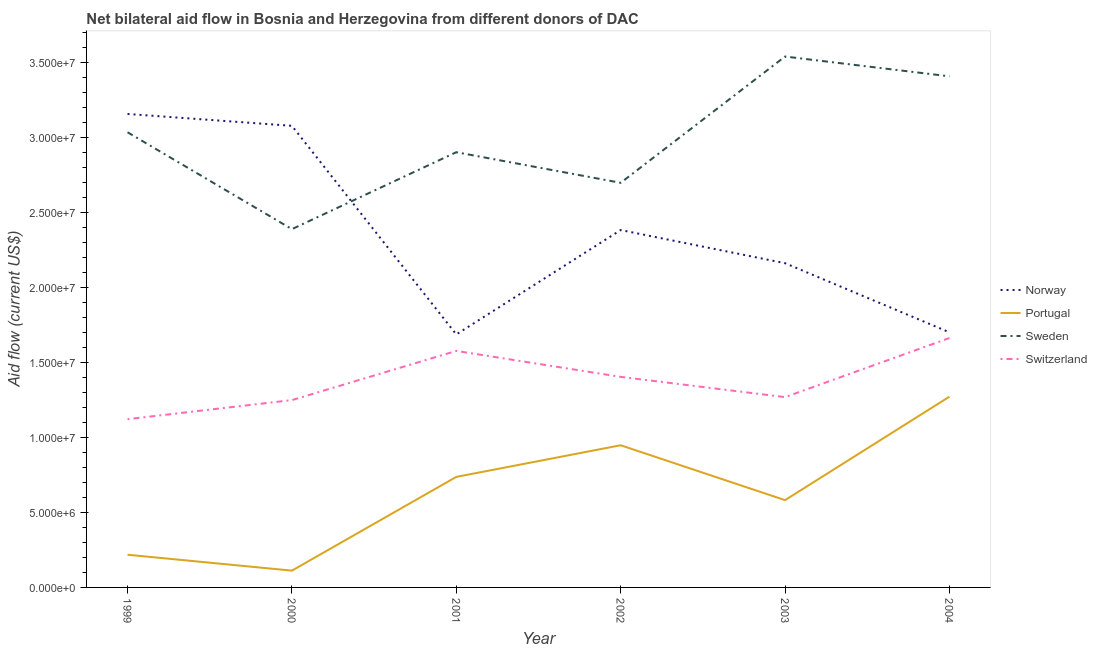Does the line corresponding to amount of aid given by portugal intersect with the line corresponding to amount of aid given by sweden?
Make the answer very short. No. What is the amount of aid given by sweden in 2003?
Offer a very short reply. 3.54e+07. Across all years, what is the maximum amount of aid given by switzerland?
Give a very brief answer. 1.66e+07. Across all years, what is the minimum amount of aid given by switzerland?
Keep it short and to the point. 1.12e+07. In which year was the amount of aid given by sweden minimum?
Offer a terse response. 2000. What is the total amount of aid given by norway in the graph?
Your answer should be compact. 1.42e+08. What is the difference between the amount of aid given by norway in 1999 and that in 2004?
Make the answer very short. 1.46e+07. What is the difference between the amount of aid given by sweden in 2000 and the amount of aid given by norway in 1999?
Provide a short and direct response. -7.68e+06. What is the average amount of aid given by sweden per year?
Make the answer very short. 3.00e+07. In the year 1999, what is the difference between the amount of aid given by switzerland and amount of aid given by portugal?
Keep it short and to the point. 9.04e+06. In how many years, is the amount of aid given by norway greater than 31000000 US$?
Offer a very short reply. 1. What is the ratio of the amount of aid given by sweden in 2000 to that in 2001?
Provide a succinct answer. 0.82. What is the difference between the highest and the second highest amount of aid given by norway?
Offer a very short reply. 7.90e+05. What is the difference between the highest and the lowest amount of aid given by norway?
Make the answer very short. 1.47e+07. In how many years, is the amount of aid given by switzerland greater than the average amount of aid given by switzerland taken over all years?
Your answer should be compact. 3. Is the sum of the amount of aid given by sweden in 2000 and 2002 greater than the maximum amount of aid given by portugal across all years?
Ensure brevity in your answer.  Yes. Is it the case that in every year, the sum of the amount of aid given by switzerland and amount of aid given by portugal is greater than the sum of amount of aid given by sweden and amount of aid given by norway?
Provide a short and direct response. No. Is the amount of aid given by portugal strictly greater than the amount of aid given by norway over the years?
Your response must be concise. No. Is the amount of aid given by portugal strictly less than the amount of aid given by sweden over the years?
Ensure brevity in your answer.  Yes. How many lines are there?
Ensure brevity in your answer.  4. How many years are there in the graph?
Provide a short and direct response. 6. Where does the legend appear in the graph?
Ensure brevity in your answer.  Center right. How many legend labels are there?
Make the answer very short. 4. What is the title of the graph?
Keep it short and to the point. Net bilateral aid flow in Bosnia and Herzegovina from different donors of DAC. Does "Public sector management" appear as one of the legend labels in the graph?
Your answer should be compact. No. What is the label or title of the X-axis?
Ensure brevity in your answer.  Year. What is the label or title of the Y-axis?
Your answer should be compact. Aid flow (current US$). What is the Aid flow (current US$) of Norway in 1999?
Provide a succinct answer. 3.16e+07. What is the Aid flow (current US$) of Portugal in 1999?
Give a very brief answer. 2.18e+06. What is the Aid flow (current US$) of Sweden in 1999?
Offer a very short reply. 3.04e+07. What is the Aid flow (current US$) in Switzerland in 1999?
Your answer should be very brief. 1.12e+07. What is the Aid flow (current US$) in Norway in 2000?
Make the answer very short. 3.08e+07. What is the Aid flow (current US$) of Portugal in 2000?
Provide a short and direct response. 1.12e+06. What is the Aid flow (current US$) of Sweden in 2000?
Keep it short and to the point. 2.39e+07. What is the Aid flow (current US$) in Switzerland in 2000?
Keep it short and to the point. 1.25e+07. What is the Aid flow (current US$) of Norway in 2001?
Provide a succinct answer. 1.69e+07. What is the Aid flow (current US$) of Portugal in 2001?
Make the answer very short. 7.37e+06. What is the Aid flow (current US$) in Sweden in 2001?
Your answer should be compact. 2.90e+07. What is the Aid flow (current US$) in Switzerland in 2001?
Provide a succinct answer. 1.58e+07. What is the Aid flow (current US$) of Norway in 2002?
Your response must be concise. 2.38e+07. What is the Aid flow (current US$) in Portugal in 2002?
Keep it short and to the point. 9.48e+06. What is the Aid flow (current US$) of Sweden in 2002?
Your answer should be very brief. 2.70e+07. What is the Aid flow (current US$) of Switzerland in 2002?
Make the answer very short. 1.40e+07. What is the Aid flow (current US$) in Norway in 2003?
Offer a very short reply. 2.16e+07. What is the Aid flow (current US$) in Portugal in 2003?
Your answer should be very brief. 5.82e+06. What is the Aid flow (current US$) of Sweden in 2003?
Keep it short and to the point. 3.54e+07. What is the Aid flow (current US$) of Switzerland in 2003?
Keep it short and to the point. 1.27e+07. What is the Aid flow (current US$) of Norway in 2004?
Keep it short and to the point. 1.70e+07. What is the Aid flow (current US$) of Portugal in 2004?
Keep it short and to the point. 1.27e+07. What is the Aid flow (current US$) of Sweden in 2004?
Keep it short and to the point. 3.41e+07. What is the Aid flow (current US$) of Switzerland in 2004?
Your answer should be very brief. 1.66e+07. Across all years, what is the maximum Aid flow (current US$) in Norway?
Offer a very short reply. 3.16e+07. Across all years, what is the maximum Aid flow (current US$) in Portugal?
Your response must be concise. 1.27e+07. Across all years, what is the maximum Aid flow (current US$) of Sweden?
Provide a succinct answer. 3.54e+07. Across all years, what is the maximum Aid flow (current US$) of Switzerland?
Offer a very short reply. 1.66e+07. Across all years, what is the minimum Aid flow (current US$) in Norway?
Ensure brevity in your answer.  1.69e+07. Across all years, what is the minimum Aid flow (current US$) in Portugal?
Your response must be concise. 1.12e+06. Across all years, what is the minimum Aid flow (current US$) of Sweden?
Provide a short and direct response. 2.39e+07. Across all years, what is the minimum Aid flow (current US$) in Switzerland?
Your answer should be very brief. 1.12e+07. What is the total Aid flow (current US$) in Norway in the graph?
Your answer should be compact. 1.42e+08. What is the total Aid flow (current US$) in Portugal in the graph?
Give a very brief answer. 3.87e+07. What is the total Aid flow (current US$) of Sweden in the graph?
Provide a short and direct response. 1.80e+08. What is the total Aid flow (current US$) of Switzerland in the graph?
Offer a terse response. 8.28e+07. What is the difference between the Aid flow (current US$) in Norway in 1999 and that in 2000?
Provide a short and direct response. 7.90e+05. What is the difference between the Aid flow (current US$) in Portugal in 1999 and that in 2000?
Provide a short and direct response. 1.06e+06. What is the difference between the Aid flow (current US$) in Sweden in 1999 and that in 2000?
Keep it short and to the point. 6.46e+06. What is the difference between the Aid flow (current US$) of Switzerland in 1999 and that in 2000?
Keep it short and to the point. -1.27e+06. What is the difference between the Aid flow (current US$) of Norway in 1999 and that in 2001?
Offer a very short reply. 1.47e+07. What is the difference between the Aid flow (current US$) of Portugal in 1999 and that in 2001?
Provide a short and direct response. -5.19e+06. What is the difference between the Aid flow (current US$) in Sweden in 1999 and that in 2001?
Give a very brief answer. 1.33e+06. What is the difference between the Aid flow (current US$) in Switzerland in 1999 and that in 2001?
Offer a terse response. -4.55e+06. What is the difference between the Aid flow (current US$) of Norway in 1999 and that in 2002?
Give a very brief answer. 7.74e+06. What is the difference between the Aid flow (current US$) of Portugal in 1999 and that in 2002?
Provide a short and direct response. -7.30e+06. What is the difference between the Aid flow (current US$) in Sweden in 1999 and that in 2002?
Make the answer very short. 3.37e+06. What is the difference between the Aid flow (current US$) of Switzerland in 1999 and that in 2002?
Your answer should be compact. -2.82e+06. What is the difference between the Aid flow (current US$) of Norway in 1999 and that in 2003?
Your answer should be compact. 9.95e+06. What is the difference between the Aid flow (current US$) in Portugal in 1999 and that in 2003?
Your answer should be very brief. -3.64e+06. What is the difference between the Aid flow (current US$) of Sweden in 1999 and that in 2003?
Make the answer very short. -5.05e+06. What is the difference between the Aid flow (current US$) in Switzerland in 1999 and that in 2003?
Your answer should be very brief. -1.47e+06. What is the difference between the Aid flow (current US$) in Norway in 1999 and that in 2004?
Keep it short and to the point. 1.46e+07. What is the difference between the Aid flow (current US$) of Portugal in 1999 and that in 2004?
Provide a short and direct response. -1.05e+07. What is the difference between the Aid flow (current US$) of Sweden in 1999 and that in 2004?
Make the answer very short. -3.73e+06. What is the difference between the Aid flow (current US$) in Switzerland in 1999 and that in 2004?
Offer a very short reply. -5.41e+06. What is the difference between the Aid flow (current US$) of Norway in 2000 and that in 2001?
Give a very brief answer. 1.39e+07. What is the difference between the Aid flow (current US$) in Portugal in 2000 and that in 2001?
Make the answer very short. -6.25e+06. What is the difference between the Aid flow (current US$) of Sweden in 2000 and that in 2001?
Keep it short and to the point. -5.13e+06. What is the difference between the Aid flow (current US$) of Switzerland in 2000 and that in 2001?
Your response must be concise. -3.28e+06. What is the difference between the Aid flow (current US$) of Norway in 2000 and that in 2002?
Your answer should be very brief. 6.95e+06. What is the difference between the Aid flow (current US$) of Portugal in 2000 and that in 2002?
Your answer should be compact. -8.36e+06. What is the difference between the Aid flow (current US$) in Sweden in 2000 and that in 2002?
Your response must be concise. -3.09e+06. What is the difference between the Aid flow (current US$) in Switzerland in 2000 and that in 2002?
Your response must be concise. -1.55e+06. What is the difference between the Aid flow (current US$) in Norway in 2000 and that in 2003?
Your response must be concise. 9.16e+06. What is the difference between the Aid flow (current US$) of Portugal in 2000 and that in 2003?
Provide a short and direct response. -4.70e+06. What is the difference between the Aid flow (current US$) of Sweden in 2000 and that in 2003?
Keep it short and to the point. -1.15e+07. What is the difference between the Aid flow (current US$) in Switzerland in 2000 and that in 2003?
Provide a short and direct response. -2.00e+05. What is the difference between the Aid flow (current US$) of Norway in 2000 and that in 2004?
Provide a short and direct response. 1.38e+07. What is the difference between the Aid flow (current US$) of Portugal in 2000 and that in 2004?
Give a very brief answer. -1.16e+07. What is the difference between the Aid flow (current US$) in Sweden in 2000 and that in 2004?
Your answer should be very brief. -1.02e+07. What is the difference between the Aid flow (current US$) in Switzerland in 2000 and that in 2004?
Make the answer very short. -4.14e+06. What is the difference between the Aid flow (current US$) in Norway in 2001 and that in 2002?
Make the answer very short. -6.96e+06. What is the difference between the Aid flow (current US$) in Portugal in 2001 and that in 2002?
Provide a short and direct response. -2.11e+06. What is the difference between the Aid flow (current US$) of Sweden in 2001 and that in 2002?
Ensure brevity in your answer.  2.04e+06. What is the difference between the Aid flow (current US$) of Switzerland in 2001 and that in 2002?
Keep it short and to the point. 1.73e+06. What is the difference between the Aid flow (current US$) in Norway in 2001 and that in 2003?
Your answer should be compact. -4.75e+06. What is the difference between the Aid flow (current US$) in Portugal in 2001 and that in 2003?
Make the answer very short. 1.55e+06. What is the difference between the Aid flow (current US$) of Sweden in 2001 and that in 2003?
Your answer should be very brief. -6.38e+06. What is the difference between the Aid flow (current US$) in Switzerland in 2001 and that in 2003?
Your answer should be very brief. 3.08e+06. What is the difference between the Aid flow (current US$) in Norway in 2001 and that in 2004?
Offer a terse response. -1.40e+05. What is the difference between the Aid flow (current US$) of Portugal in 2001 and that in 2004?
Keep it short and to the point. -5.35e+06. What is the difference between the Aid flow (current US$) of Sweden in 2001 and that in 2004?
Offer a terse response. -5.06e+06. What is the difference between the Aid flow (current US$) in Switzerland in 2001 and that in 2004?
Provide a succinct answer. -8.60e+05. What is the difference between the Aid flow (current US$) in Norway in 2002 and that in 2003?
Your answer should be very brief. 2.21e+06. What is the difference between the Aid flow (current US$) in Portugal in 2002 and that in 2003?
Make the answer very short. 3.66e+06. What is the difference between the Aid flow (current US$) in Sweden in 2002 and that in 2003?
Provide a succinct answer. -8.42e+06. What is the difference between the Aid flow (current US$) in Switzerland in 2002 and that in 2003?
Your response must be concise. 1.35e+06. What is the difference between the Aid flow (current US$) in Norway in 2002 and that in 2004?
Give a very brief answer. 6.82e+06. What is the difference between the Aid flow (current US$) of Portugal in 2002 and that in 2004?
Your answer should be very brief. -3.24e+06. What is the difference between the Aid flow (current US$) in Sweden in 2002 and that in 2004?
Offer a terse response. -7.10e+06. What is the difference between the Aid flow (current US$) in Switzerland in 2002 and that in 2004?
Offer a very short reply. -2.59e+06. What is the difference between the Aid flow (current US$) in Norway in 2003 and that in 2004?
Keep it short and to the point. 4.61e+06. What is the difference between the Aid flow (current US$) in Portugal in 2003 and that in 2004?
Give a very brief answer. -6.90e+06. What is the difference between the Aid flow (current US$) of Sweden in 2003 and that in 2004?
Your response must be concise. 1.32e+06. What is the difference between the Aid flow (current US$) in Switzerland in 2003 and that in 2004?
Your answer should be compact. -3.94e+06. What is the difference between the Aid flow (current US$) in Norway in 1999 and the Aid flow (current US$) in Portugal in 2000?
Ensure brevity in your answer.  3.04e+07. What is the difference between the Aid flow (current US$) of Norway in 1999 and the Aid flow (current US$) of Sweden in 2000?
Offer a terse response. 7.68e+06. What is the difference between the Aid flow (current US$) of Norway in 1999 and the Aid flow (current US$) of Switzerland in 2000?
Your response must be concise. 1.91e+07. What is the difference between the Aid flow (current US$) in Portugal in 1999 and the Aid flow (current US$) in Sweden in 2000?
Give a very brief answer. -2.17e+07. What is the difference between the Aid flow (current US$) in Portugal in 1999 and the Aid flow (current US$) in Switzerland in 2000?
Offer a very short reply. -1.03e+07. What is the difference between the Aid flow (current US$) of Sweden in 1999 and the Aid flow (current US$) of Switzerland in 2000?
Provide a succinct answer. 1.79e+07. What is the difference between the Aid flow (current US$) of Norway in 1999 and the Aid flow (current US$) of Portugal in 2001?
Your answer should be very brief. 2.42e+07. What is the difference between the Aid flow (current US$) in Norway in 1999 and the Aid flow (current US$) in Sweden in 2001?
Provide a succinct answer. 2.55e+06. What is the difference between the Aid flow (current US$) in Norway in 1999 and the Aid flow (current US$) in Switzerland in 2001?
Your answer should be compact. 1.58e+07. What is the difference between the Aid flow (current US$) of Portugal in 1999 and the Aid flow (current US$) of Sweden in 2001?
Provide a short and direct response. -2.68e+07. What is the difference between the Aid flow (current US$) of Portugal in 1999 and the Aid flow (current US$) of Switzerland in 2001?
Make the answer very short. -1.36e+07. What is the difference between the Aid flow (current US$) in Sweden in 1999 and the Aid flow (current US$) in Switzerland in 2001?
Your answer should be very brief. 1.46e+07. What is the difference between the Aid flow (current US$) of Norway in 1999 and the Aid flow (current US$) of Portugal in 2002?
Give a very brief answer. 2.21e+07. What is the difference between the Aid flow (current US$) of Norway in 1999 and the Aid flow (current US$) of Sweden in 2002?
Make the answer very short. 4.59e+06. What is the difference between the Aid flow (current US$) of Norway in 1999 and the Aid flow (current US$) of Switzerland in 2002?
Give a very brief answer. 1.75e+07. What is the difference between the Aid flow (current US$) in Portugal in 1999 and the Aid flow (current US$) in Sweden in 2002?
Provide a short and direct response. -2.48e+07. What is the difference between the Aid flow (current US$) of Portugal in 1999 and the Aid flow (current US$) of Switzerland in 2002?
Offer a terse response. -1.19e+07. What is the difference between the Aid flow (current US$) of Sweden in 1999 and the Aid flow (current US$) of Switzerland in 2002?
Offer a very short reply. 1.63e+07. What is the difference between the Aid flow (current US$) in Norway in 1999 and the Aid flow (current US$) in Portugal in 2003?
Give a very brief answer. 2.58e+07. What is the difference between the Aid flow (current US$) of Norway in 1999 and the Aid flow (current US$) of Sweden in 2003?
Make the answer very short. -3.83e+06. What is the difference between the Aid flow (current US$) in Norway in 1999 and the Aid flow (current US$) in Switzerland in 2003?
Your answer should be very brief. 1.89e+07. What is the difference between the Aid flow (current US$) of Portugal in 1999 and the Aid flow (current US$) of Sweden in 2003?
Your answer should be very brief. -3.32e+07. What is the difference between the Aid flow (current US$) of Portugal in 1999 and the Aid flow (current US$) of Switzerland in 2003?
Your answer should be very brief. -1.05e+07. What is the difference between the Aid flow (current US$) of Sweden in 1999 and the Aid flow (current US$) of Switzerland in 2003?
Provide a succinct answer. 1.77e+07. What is the difference between the Aid flow (current US$) of Norway in 1999 and the Aid flow (current US$) of Portugal in 2004?
Offer a very short reply. 1.88e+07. What is the difference between the Aid flow (current US$) of Norway in 1999 and the Aid flow (current US$) of Sweden in 2004?
Keep it short and to the point. -2.51e+06. What is the difference between the Aid flow (current US$) in Norway in 1999 and the Aid flow (current US$) in Switzerland in 2004?
Ensure brevity in your answer.  1.49e+07. What is the difference between the Aid flow (current US$) in Portugal in 1999 and the Aid flow (current US$) in Sweden in 2004?
Ensure brevity in your answer.  -3.19e+07. What is the difference between the Aid flow (current US$) of Portugal in 1999 and the Aid flow (current US$) of Switzerland in 2004?
Provide a succinct answer. -1.44e+07. What is the difference between the Aid flow (current US$) in Sweden in 1999 and the Aid flow (current US$) in Switzerland in 2004?
Your answer should be compact. 1.37e+07. What is the difference between the Aid flow (current US$) of Norway in 2000 and the Aid flow (current US$) of Portugal in 2001?
Make the answer very short. 2.34e+07. What is the difference between the Aid flow (current US$) of Norway in 2000 and the Aid flow (current US$) of Sweden in 2001?
Provide a succinct answer. 1.76e+06. What is the difference between the Aid flow (current US$) in Norway in 2000 and the Aid flow (current US$) in Switzerland in 2001?
Offer a very short reply. 1.50e+07. What is the difference between the Aid flow (current US$) in Portugal in 2000 and the Aid flow (current US$) in Sweden in 2001?
Your answer should be very brief. -2.79e+07. What is the difference between the Aid flow (current US$) in Portugal in 2000 and the Aid flow (current US$) in Switzerland in 2001?
Your response must be concise. -1.46e+07. What is the difference between the Aid flow (current US$) of Sweden in 2000 and the Aid flow (current US$) of Switzerland in 2001?
Provide a succinct answer. 8.12e+06. What is the difference between the Aid flow (current US$) in Norway in 2000 and the Aid flow (current US$) in Portugal in 2002?
Your answer should be very brief. 2.13e+07. What is the difference between the Aid flow (current US$) in Norway in 2000 and the Aid flow (current US$) in Sweden in 2002?
Offer a terse response. 3.80e+06. What is the difference between the Aid flow (current US$) of Norway in 2000 and the Aid flow (current US$) of Switzerland in 2002?
Ensure brevity in your answer.  1.67e+07. What is the difference between the Aid flow (current US$) in Portugal in 2000 and the Aid flow (current US$) in Sweden in 2002?
Offer a very short reply. -2.59e+07. What is the difference between the Aid flow (current US$) of Portugal in 2000 and the Aid flow (current US$) of Switzerland in 2002?
Your answer should be very brief. -1.29e+07. What is the difference between the Aid flow (current US$) of Sweden in 2000 and the Aid flow (current US$) of Switzerland in 2002?
Provide a short and direct response. 9.85e+06. What is the difference between the Aid flow (current US$) in Norway in 2000 and the Aid flow (current US$) in Portugal in 2003?
Your answer should be compact. 2.50e+07. What is the difference between the Aid flow (current US$) in Norway in 2000 and the Aid flow (current US$) in Sweden in 2003?
Your answer should be very brief. -4.62e+06. What is the difference between the Aid flow (current US$) in Norway in 2000 and the Aid flow (current US$) in Switzerland in 2003?
Make the answer very short. 1.81e+07. What is the difference between the Aid flow (current US$) of Portugal in 2000 and the Aid flow (current US$) of Sweden in 2003?
Your answer should be very brief. -3.43e+07. What is the difference between the Aid flow (current US$) in Portugal in 2000 and the Aid flow (current US$) in Switzerland in 2003?
Give a very brief answer. -1.16e+07. What is the difference between the Aid flow (current US$) of Sweden in 2000 and the Aid flow (current US$) of Switzerland in 2003?
Make the answer very short. 1.12e+07. What is the difference between the Aid flow (current US$) in Norway in 2000 and the Aid flow (current US$) in Portugal in 2004?
Ensure brevity in your answer.  1.81e+07. What is the difference between the Aid flow (current US$) in Norway in 2000 and the Aid flow (current US$) in Sweden in 2004?
Your answer should be very brief. -3.30e+06. What is the difference between the Aid flow (current US$) in Norway in 2000 and the Aid flow (current US$) in Switzerland in 2004?
Give a very brief answer. 1.42e+07. What is the difference between the Aid flow (current US$) in Portugal in 2000 and the Aid flow (current US$) in Sweden in 2004?
Offer a very short reply. -3.30e+07. What is the difference between the Aid flow (current US$) of Portugal in 2000 and the Aid flow (current US$) of Switzerland in 2004?
Offer a very short reply. -1.55e+07. What is the difference between the Aid flow (current US$) of Sweden in 2000 and the Aid flow (current US$) of Switzerland in 2004?
Make the answer very short. 7.26e+06. What is the difference between the Aid flow (current US$) of Norway in 2001 and the Aid flow (current US$) of Portugal in 2002?
Make the answer very short. 7.39e+06. What is the difference between the Aid flow (current US$) of Norway in 2001 and the Aid flow (current US$) of Sweden in 2002?
Give a very brief answer. -1.01e+07. What is the difference between the Aid flow (current US$) of Norway in 2001 and the Aid flow (current US$) of Switzerland in 2002?
Your response must be concise. 2.83e+06. What is the difference between the Aid flow (current US$) of Portugal in 2001 and the Aid flow (current US$) of Sweden in 2002?
Offer a very short reply. -1.96e+07. What is the difference between the Aid flow (current US$) of Portugal in 2001 and the Aid flow (current US$) of Switzerland in 2002?
Offer a terse response. -6.67e+06. What is the difference between the Aid flow (current US$) of Sweden in 2001 and the Aid flow (current US$) of Switzerland in 2002?
Provide a succinct answer. 1.50e+07. What is the difference between the Aid flow (current US$) of Norway in 2001 and the Aid flow (current US$) of Portugal in 2003?
Keep it short and to the point. 1.10e+07. What is the difference between the Aid flow (current US$) of Norway in 2001 and the Aid flow (current US$) of Sweden in 2003?
Ensure brevity in your answer.  -1.85e+07. What is the difference between the Aid flow (current US$) of Norway in 2001 and the Aid flow (current US$) of Switzerland in 2003?
Your answer should be compact. 4.18e+06. What is the difference between the Aid flow (current US$) of Portugal in 2001 and the Aid flow (current US$) of Sweden in 2003?
Your answer should be compact. -2.80e+07. What is the difference between the Aid flow (current US$) in Portugal in 2001 and the Aid flow (current US$) in Switzerland in 2003?
Offer a very short reply. -5.32e+06. What is the difference between the Aid flow (current US$) of Sweden in 2001 and the Aid flow (current US$) of Switzerland in 2003?
Offer a very short reply. 1.63e+07. What is the difference between the Aid flow (current US$) of Norway in 2001 and the Aid flow (current US$) of Portugal in 2004?
Your answer should be compact. 4.15e+06. What is the difference between the Aid flow (current US$) of Norway in 2001 and the Aid flow (current US$) of Sweden in 2004?
Offer a terse response. -1.72e+07. What is the difference between the Aid flow (current US$) in Norway in 2001 and the Aid flow (current US$) in Switzerland in 2004?
Make the answer very short. 2.40e+05. What is the difference between the Aid flow (current US$) in Portugal in 2001 and the Aid flow (current US$) in Sweden in 2004?
Provide a short and direct response. -2.67e+07. What is the difference between the Aid flow (current US$) of Portugal in 2001 and the Aid flow (current US$) of Switzerland in 2004?
Ensure brevity in your answer.  -9.26e+06. What is the difference between the Aid flow (current US$) of Sweden in 2001 and the Aid flow (current US$) of Switzerland in 2004?
Offer a very short reply. 1.24e+07. What is the difference between the Aid flow (current US$) in Norway in 2002 and the Aid flow (current US$) in Portugal in 2003?
Keep it short and to the point. 1.80e+07. What is the difference between the Aid flow (current US$) of Norway in 2002 and the Aid flow (current US$) of Sweden in 2003?
Make the answer very short. -1.16e+07. What is the difference between the Aid flow (current US$) in Norway in 2002 and the Aid flow (current US$) in Switzerland in 2003?
Ensure brevity in your answer.  1.11e+07. What is the difference between the Aid flow (current US$) of Portugal in 2002 and the Aid flow (current US$) of Sweden in 2003?
Keep it short and to the point. -2.59e+07. What is the difference between the Aid flow (current US$) in Portugal in 2002 and the Aid flow (current US$) in Switzerland in 2003?
Your answer should be compact. -3.21e+06. What is the difference between the Aid flow (current US$) in Sweden in 2002 and the Aid flow (current US$) in Switzerland in 2003?
Make the answer very short. 1.43e+07. What is the difference between the Aid flow (current US$) in Norway in 2002 and the Aid flow (current US$) in Portugal in 2004?
Your answer should be very brief. 1.11e+07. What is the difference between the Aid flow (current US$) in Norway in 2002 and the Aid flow (current US$) in Sweden in 2004?
Offer a terse response. -1.02e+07. What is the difference between the Aid flow (current US$) in Norway in 2002 and the Aid flow (current US$) in Switzerland in 2004?
Offer a terse response. 7.20e+06. What is the difference between the Aid flow (current US$) of Portugal in 2002 and the Aid flow (current US$) of Sweden in 2004?
Offer a terse response. -2.46e+07. What is the difference between the Aid flow (current US$) of Portugal in 2002 and the Aid flow (current US$) of Switzerland in 2004?
Give a very brief answer. -7.15e+06. What is the difference between the Aid flow (current US$) of Sweden in 2002 and the Aid flow (current US$) of Switzerland in 2004?
Offer a very short reply. 1.04e+07. What is the difference between the Aid flow (current US$) of Norway in 2003 and the Aid flow (current US$) of Portugal in 2004?
Offer a very short reply. 8.90e+06. What is the difference between the Aid flow (current US$) in Norway in 2003 and the Aid flow (current US$) in Sweden in 2004?
Offer a very short reply. -1.25e+07. What is the difference between the Aid flow (current US$) of Norway in 2003 and the Aid flow (current US$) of Switzerland in 2004?
Your answer should be very brief. 4.99e+06. What is the difference between the Aid flow (current US$) of Portugal in 2003 and the Aid flow (current US$) of Sweden in 2004?
Give a very brief answer. -2.83e+07. What is the difference between the Aid flow (current US$) of Portugal in 2003 and the Aid flow (current US$) of Switzerland in 2004?
Offer a terse response. -1.08e+07. What is the difference between the Aid flow (current US$) of Sweden in 2003 and the Aid flow (current US$) of Switzerland in 2004?
Your answer should be compact. 1.88e+07. What is the average Aid flow (current US$) of Norway per year?
Provide a short and direct response. 2.36e+07. What is the average Aid flow (current US$) of Portugal per year?
Make the answer very short. 6.45e+06. What is the average Aid flow (current US$) of Sweden per year?
Provide a short and direct response. 3.00e+07. What is the average Aid flow (current US$) of Switzerland per year?
Ensure brevity in your answer.  1.38e+07. In the year 1999, what is the difference between the Aid flow (current US$) of Norway and Aid flow (current US$) of Portugal?
Your response must be concise. 2.94e+07. In the year 1999, what is the difference between the Aid flow (current US$) of Norway and Aid flow (current US$) of Sweden?
Ensure brevity in your answer.  1.22e+06. In the year 1999, what is the difference between the Aid flow (current US$) of Norway and Aid flow (current US$) of Switzerland?
Provide a short and direct response. 2.04e+07. In the year 1999, what is the difference between the Aid flow (current US$) in Portugal and Aid flow (current US$) in Sweden?
Ensure brevity in your answer.  -2.82e+07. In the year 1999, what is the difference between the Aid flow (current US$) of Portugal and Aid flow (current US$) of Switzerland?
Give a very brief answer. -9.04e+06. In the year 1999, what is the difference between the Aid flow (current US$) of Sweden and Aid flow (current US$) of Switzerland?
Offer a terse response. 1.91e+07. In the year 2000, what is the difference between the Aid flow (current US$) of Norway and Aid flow (current US$) of Portugal?
Ensure brevity in your answer.  2.97e+07. In the year 2000, what is the difference between the Aid flow (current US$) in Norway and Aid flow (current US$) in Sweden?
Make the answer very short. 6.89e+06. In the year 2000, what is the difference between the Aid flow (current US$) in Norway and Aid flow (current US$) in Switzerland?
Offer a very short reply. 1.83e+07. In the year 2000, what is the difference between the Aid flow (current US$) in Portugal and Aid flow (current US$) in Sweden?
Make the answer very short. -2.28e+07. In the year 2000, what is the difference between the Aid flow (current US$) of Portugal and Aid flow (current US$) of Switzerland?
Provide a succinct answer. -1.14e+07. In the year 2000, what is the difference between the Aid flow (current US$) of Sweden and Aid flow (current US$) of Switzerland?
Keep it short and to the point. 1.14e+07. In the year 2001, what is the difference between the Aid flow (current US$) in Norway and Aid flow (current US$) in Portugal?
Your answer should be very brief. 9.50e+06. In the year 2001, what is the difference between the Aid flow (current US$) in Norway and Aid flow (current US$) in Sweden?
Make the answer very short. -1.22e+07. In the year 2001, what is the difference between the Aid flow (current US$) of Norway and Aid flow (current US$) of Switzerland?
Your response must be concise. 1.10e+06. In the year 2001, what is the difference between the Aid flow (current US$) in Portugal and Aid flow (current US$) in Sweden?
Offer a terse response. -2.16e+07. In the year 2001, what is the difference between the Aid flow (current US$) of Portugal and Aid flow (current US$) of Switzerland?
Your answer should be compact. -8.40e+06. In the year 2001, what is the difference between the Aid flow (current US$) of Sweden and Aid flow (current US$) of Switzerland?
Offer a very short reply. 1.32e+07. In the year 2002, what is the difference between the Aid flow (current US$) in Norway and Aid flow (current US$) in Portugal?
Your answer should be compact. 1.44e+07. In the year 2002, what is the difference between the Aid flow (current US$) in Norway and Aid flow (current US$) in Sweden?
Make the answer very short. -3.15e+06. In the year 2002, what is the difference between the Aid flow (current US$) in Norway and Aid flow (current US$) in Switzerland?
Offer a very short reply. 9.79e+06. In the year 2002, what is the difference between the Aid flow (current US$) of Portugal and Aid flow (current US$) of Sweden?
Your answer should be very brief. -1.75e+07. In the year 2002, what is the difference between the Aid flow (current US$) of Portugal and Aid flow (current US$) of Switzerland?
Ensure brevity in your answer.  -4.56e+06. In the year 2002, what is the difference between the Aid flow (current US$) of Sweden and Aid flow (current US$) of Switzerland?
Offer a terse response. 1.29e+07. In the year 2003, what is the difference between the Aid flow (current US$) of Norway and Aid flow (current US$) of Portugal?
Offer a terse response. 1.58e+07. In the year 2003, what is the difference between the Aid flow (current US$) in Norway and Aid flow (current US$) in Sweden?
Make the answer very short. -1.38e+07. In the year 2003, what is the difference between the Aid flow (current US$) in Norway and Aid flow (current US$) in Switzerland?
Your answer should be compact. 8.93e+06. In the year 2003, what is the difference between the Aid flow (current US$) of Portugal and Aid flow (current US$) of Sweden?
Offer a very short reply. -2.96e+07. In the year 2003, what is the difference between the Aid flow (current US$) in Portugal and Aid flow (current US$) in Switzerland?
Make the answer very short. -6.87e+06. In the year 2003, what is the difference between the Aid flow (current US$) of Sweden and Aid flow (current US$) of Switzerland?
Make the answer very short. 2.27e+07. In the year 2004, what is the difference between the Aid flow (current US$) in Norway and Aid flow (current US$) in Portugal?
Keep it short and to the point. 4.29e+06. In the year 2004, what is the difference between the Aid flow (current US$) of Norway and Aid flow (current US$) of Sweden?
Keep it short and to the point. -1.71e+07. In the year 2004, what is the difference between the Aid flow (current US$) of Portugal and Aid flow (current US$) of Sweden?
Provide a short and direct response. -2.14e+07. In the year 2004, what is the difference between the Aid flow (current US$) of Portugal and Aid flow (current US$) of Switzerland?
Ensure brevity in your answer.  -3.91e+06. In the year 2004, what is the difference between the Aid flow (current US$) of Sweden and Aid flow (current US$) of Switzerland?
Your answer should be very brief. 1.74e+07. What is the ratio of the Aid flow (current US$) of Norway in 1999 to that in 2000?
Make the answer very short. 1.03. What is the ratio of the Aid flow (current US$) in Portugal in 1999 to that in 2000?
Provide a succinct answer. 1.95. What is the ratio of the Aid flow (current US$) in Sweden in 1999 to that in 2000?
Provide a short and direct response. 1.27. What is the ratio of the Aid flow (current US$) of Switzerland in 1999 to that in 2000?
Keep it short and to the point. 0.9. What is the ratio of the Aid flow (current US$) of Norway in 1999 to that in 2001?
Ensure brevity in your answer.  1.87. What is the ratio of the Aid flow (current US$) of Portugal in 1999 to that in 2001?
Ensure brevity in your answer.  0.3. What is the ratio of the Aid flow (current US$) of Sweden in 1999 to that in 2001?
Give a very brief answer. 1.05. What is the ratio of the Aid flow (current US$) in Switzerland in 1999 to that in 2001?
Keep it short and to the point. 0.71. What is the ratio of the Aid flow (current US$) of Norway in 1999 to that in 2002?
Keep it short and to the point. 1.32. What is the ratio of the Aid flow (current US$) of Portugal in 1999 to that in 2002?
Offer a terse response. 0.23. What is the ratio of the Aid flow (current US$) in Sweden in 1999 to that in 2002?
Give a very brief answer. 1.12. What is the ratio of the Aid flow (current US$) in Switzerland in 1999 to that in 2002?
Provide a short and direct response. 0.8. What is the ratio of the Aid flow (current US$) of Norway in 1999 to that in 2003?
Your answer should be very brief. 1.46. What is the ratio of the Aid flow (current US$) in Portugal in 1999 to that in 2003?
Your answer should be compact. 0.37. What is the ratio of the Aid flow (current US$) of Sweden in 1999 to that in 2003?
Offer a very short reply. 0.86. What is the ratio of the Aid flow (current US$) of Switzerland in 1999 to that in 2003?
Keep it short and to the point. 0.88. What is the ratio of the Aid flow (current US$) of Norway in 1999 to that in 2004?
Your answer should be compact. 1.86. What is the ratio of the Aid flow (current US$) in Portugal in 1999 to that in 2004?
Your answer should be very brief. 0.17. What is the ratio of the Aid flow (current US$) in Sweden in 1999 to that in 2004?
Keep it short and to the point. 0.89. What is the ratio of the Aid flow (current US$) in Switzerland in 1999 to that in 2004?
Your answer should be compact. 0.67. What is the ratio of the Aid flow (current US$) in Norway in 2000 to that in 2001?
Your answer should be compact. 1.82. What is the ratio of the Aid flow (current US$) in Portugal in 2000 to that in 2001?
Offer a very short reply. 0.15. What is the ratio of the Aid flow (current US$) of Sweden in 2000 to that in 2001?
Your answer should be very brief. 0.82. What is the ratio of the Aid flow (current US$) of Switzerland in 2000 to that in 2001?
Your answer should be very brief. 0.79. What is the ratio of the Aid flow (current US$) in Norway in 2000 to that in 2002?
Keep it short and to the point. 1.29. What is the ratio of the Aid flow (current US$) in Portugal in 2000 to that in 2002?
Provide a short and direct response. 0.12. What is the ratio of the Aid flow (current US$) of Sweden in 2000 to that in 2002?
Your response must be concise. 0.89. What is the ratio of the Aid flow (current US$) in Switzerland in 2000 to that in 2002?
Ensure brevity in your answer.  0.89. What is the ratio of the Aid flow (current US$) in Norway in 2000 to that in 2003?
Give a very brief answer. 1.42. What is the ratio of the Aid flow (current US$) in Portugal in 2000 to that in 2003?
Give a very brief answer. 0.19. What is the ratio of the Aid flow (current US$) of Sweden in 2000 to that in 2003?
Your response must be concise. 0.67. What is the ratio of the Aid flow (current US$) in Switzerland in 2000 to that in 2003?
Offer a very short reply. 0.98. What is the ratio of the Aid flow (current US$) in Norway in 2000 to that in 2004?
Provide a succinct answer. 1.81. What is the ratio of the Aid flow (current US$) of Portugal in 2000 to that in 2004?
Offer a terse response. 0.09. What is the ratio of the Aid flow (current US$) of Sweden in 2000 to that in 2004?
Ensure brevity in your answer.  0.7. What is the ratio of the Aid flow (current US$) in Switzerland in 2000 to that in 2004?
Your response must be concise. 0.75. What is the ratio of the Aid flow (current US$) of Norway in 2001 to that in 2002?
Give a very brief answer. 0.71. What is the ratio of the Aid flow (current US$) in Portugal in 2001 to that in 2002?
Ensure brevity in your answer.  0.78. What is the ratio of the Aid flow (current US$) of Sweden in 2001 to that in 2002?
Provide a succinct answer. 1.08. What is the ratio of the Aid flow (current US$) of Switzerland in 2001 to that in 2002?
Ensure brevity in your answer.  1.12. What is the ratio of the Aid flow (current US$) of Norway in 2001 to that in 2003?
Offer a very short reply. 0.78. What is the ratio of the Aid flow (current US$) of Portugal in 2001 to that in 2003?
Ensure brevity in your answer.  1.27. What is the ratio of the Aid flow (current US$) of Sweden in 2001 to that in 2003?
Your answer should be compact. 0.82. What is the ratio of the Aid flow (current US$) of Switzerland in 2001 to that in 2003?
Ensure brevity in your answer.  1.24. What is the ratio of the Aid flow (current US$) of Norway in 2001 to that in 2004?
Your answer should be compact. 0.99. What is the ratio of the Aid flow (current US$) of Portugal in 2001 to that in 2004?
Provide a short and direct response. 0.58. What is the ratio of the Aid flow (current US$) in Sweden in 2001 to that in 2004?
Your response must be concise. 0.85. What is the ratio of the Aid flow (current US$) of Switzerland in 2001 to that in 2004?
Your answer should be compact. 0.95. What is the ratio of the Aid flow (current US$) in Norway in 2002 to that in 2003?
Provide a succinct answer. 1.1. What is the ratio of the Aid flow (current US$) in Portugal in 2002 to that in 2003?
Provide a succinct answer. 1.63. What is the ratio of the Aid flow (current US$) in Sweden in 2002 to that in 2003?
Offer a very short reply. 0.76. What is the ratio of the Aid flow (current US$) of Switzerland in 2002 to that in 2003?
Your answer should be compact. 1.11. What is the ratio of the Aid flow (current US$) of Norway in 2002 to that in 2004?
Your response must be concise. 1.4. What is the ratio of the Aid flow (current US$) of Portugal in 2002 to that in 2004?
Offer a terse response. 0.75. What is the ratio of the Aid flow (current US$) in Sweden in 2002 to that in 2004?
Provide a short and direct response. 0.79. What is the ratio of the Aid flow (current US$) in Switzerland in 2002 to that in 2004?
Make the answer very short. 0.84. What is the ratio of the Aid flow (current US$) of Norway in 2003 to that in 2004?
Provide a short and direct response. 1.27. What is the ratio of the Aid flow (current US$) in Portugal in 2003 to that in 2004?
Keep it short and to the point. 0.46. What is the ratio of the Aid flow (current US$) of Sweden in 2003 to that in 2004?
Offer a terse response. 1.04. What is the ratio of the Aid flow (current US$) of Switzerland in 2003 to that in 2004?
Provide a short and direct response. 0.76. What is the difference between the highest and the second highest Aid flow (current US$) in Norway?
Your response must be concise. 7.90e+05. What is the difference between the highest and the second highest Aid flow (current US$) in Portugal?
Your answer should be very brief. 3.24e+06. What is the difference between the highest and the second highest Aid flow (current US$) in Sweden?
Provide a short and direct response. 1.32e+06. What is the difference between the highest and the second highest Aid flow (current US$) in Switzerland?
Provide a succinct answer. 8.60e+05. What is the difference between the highest and the lowest Aid flow (current US$) of Norway?
Provide a short and direct response. 1.47e+07. What is the difference between the highest and the lowest Aid flow (current US$) in Portugal?
Your answer should be compact. 1.16e+07. What is the difference between the highest and the lowest Aid flow (current US$) of Sweden?
Provide a short and direct response. 1.15e+07. What is the difference between the highest and the lowest Aid flow (current US$) in Switzerland?
Ensure brevity in your answer.  5.41e+06. 